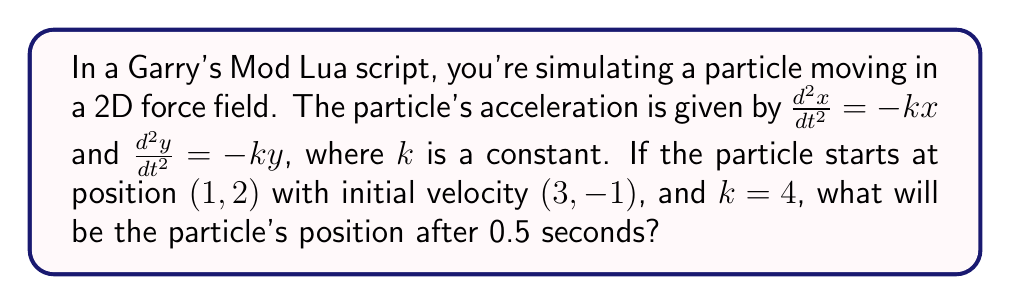Can you answer this question? To solve this problem, we need to use the theory of first-order differential equations. Let's break it down step by step:

1) First, we have two second-order differential equations:
   $$\frac{d^2x}{dt^2} = -kx$$ and $$\frac{d^2y}{dt^2} = -ky$$

2) These are harmonic oscillator equations. The general solution for each is:
   $$x(t) = A \cos(\sqrt{k}t) + B \sin(\sqrt{k}t)$$
   $$y(t) = C \cos(\sqrt{k}t) + D \sin(\sqrt{k}t)$$

3) We're given that $k = 4$, so $\sqrt{k} = 2$. Our equations become:
   $$x(t) = A \cos(2t) + B \sin(2t)$$
   $$y(t) = C \cos(2t) + D \sin(2t)$$

4) To find $A$, $B$, $C$, and $D$, we use the initial conditions:
   At $t = 0$: $x(0) = 1$, $y(0) = 2$, $x'(0) = 3$, $y'(0) = -1$

5) Applying these conditions:
   $x(0) = A = 1$
   $y(0) = C = 2$
   $x'(0) = 2B = 3$, so $B = 3/2$
   $y'(0) = 2D = -1$, so $D = -1/2$

6) Our final equations are:
   $$x(t) = \cos(2t) + \frac{3}{2} \sin(2t)$$
   $$y(t) = 2 \cos(2t) - \frac{1}{2} \sin(2t)$$

7) To find the position at $t = 0.5$, we substitute this value:
   $$x(0.5) = \cos(1) + \frac{3}{2} \sin(1)$$
   $$y(0.5) = 2 \cos(1) - \frac{1}{2} \sin(1)$$

8) Calculating these values:
   $$x(0.5) \approx 0.5403 + 1.2790 \approx 1.8193$$
   $$y(0.5) \approx 1.0807 - 0.4263 \approx 0.6544$$

Therefore, after 0.5 seconds, the particle's position will be approximately (1.8193, 0.6544).
Answer: (1.8193, 0.6544) 